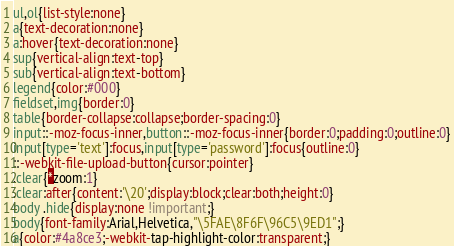Convert code to text. <code><loc_0><loc_0><loc_500><loc_500><_CSS_>ul,ol{list-style:none}
a{text-decoration:none}
a:hover{text-decoration:none}
sup{vertical-align:text-top}
sub{vertical-align:text-bottom}
legend{color:#000}
fieldset,img{border:0}
table{border-collapse:collapse;border-spacing:0}
input::-moz-focus-inner,button::-moz-focus-inner{border:0;padding:0;outline:0}
input[type='text']:focus,input[type='password']:focus{outline:0}
::-webkit-file-upload-button{cursor:pointer}
.clear{*zoom:1}
.clear:after{content:'\20';display:block;clear:both;height:0}
body .hide{display:none !important;}
body{font-family:Arial,Helvetica,"\5FAE\8F6F\96C5\9ED1";}
a{color:#4a8ce3;-webkit-tap-highlight-color:transparent;}
</code> 